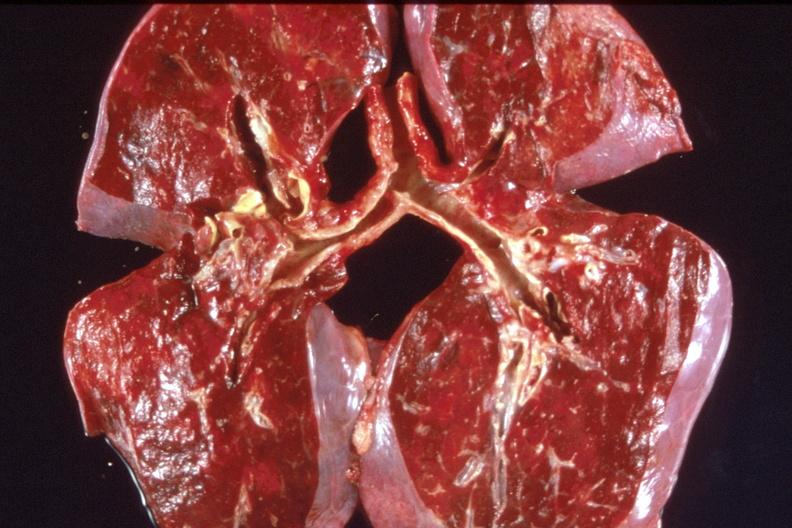what does this image show?
Answer the question using a single word or phrase. Lung 